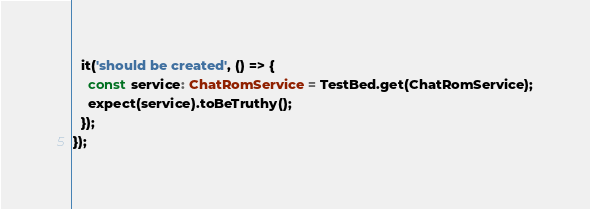Convert code to text. <code><loc_0><loc_0><loc_500><loc_500><_TypeScript_>  it('should be created', () => {
    const service: ChatRomService = TestBed.get(ChatRomService);
    expect(service).toBeTruthy();
  });
});
</code> 